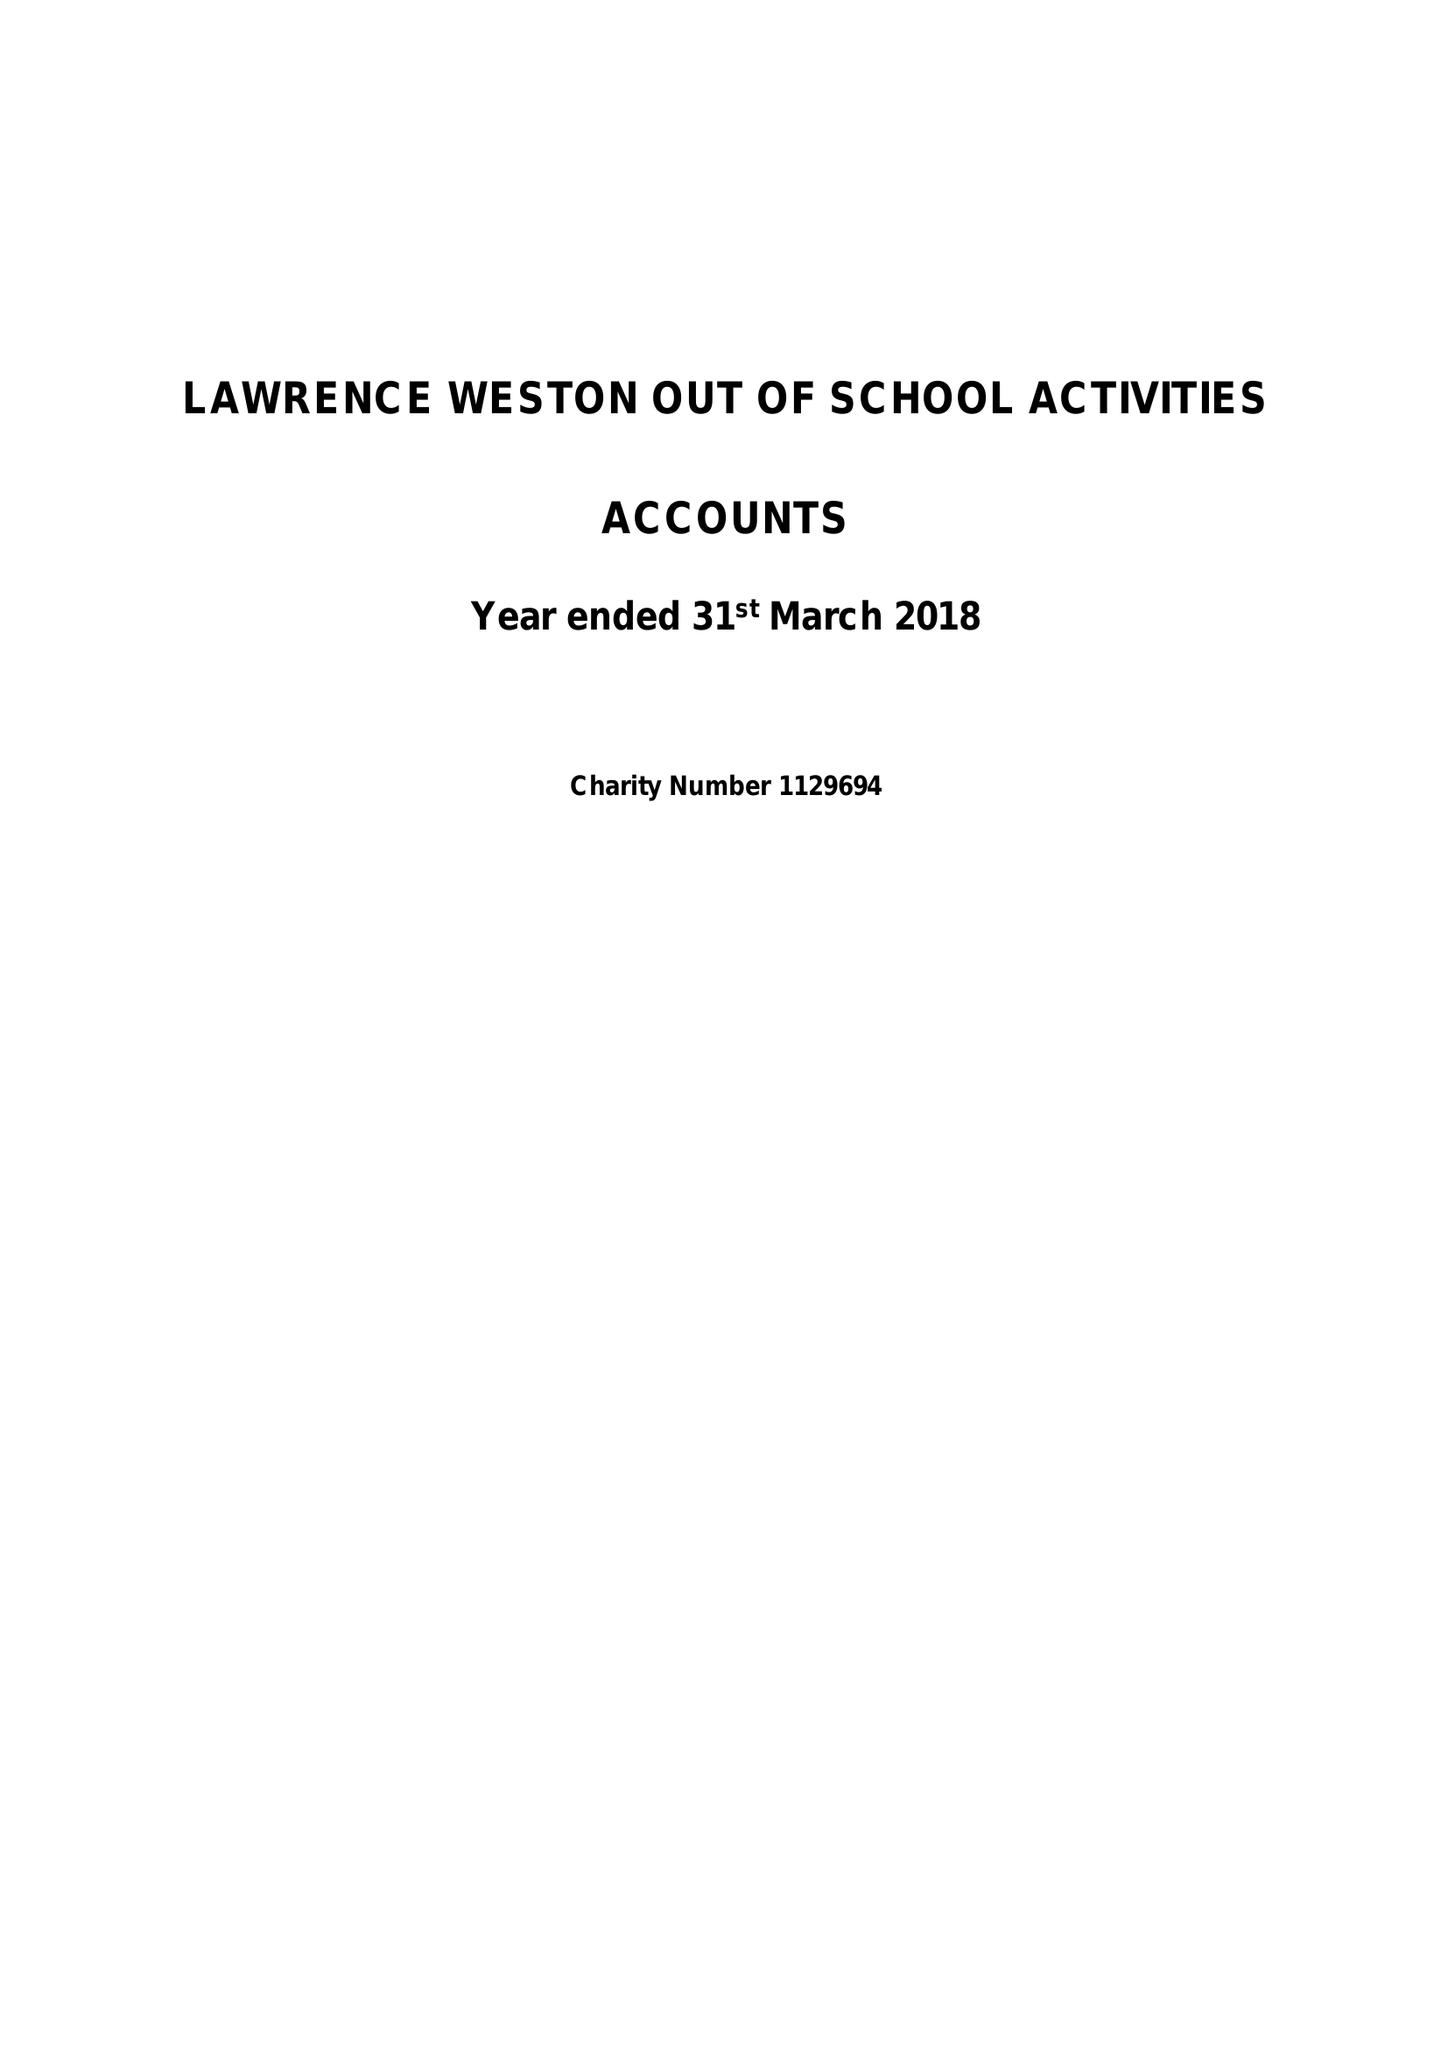What is the value for the income_annually_in_british_pounds?
Answer the question using a single word or phrase. 90189.00 